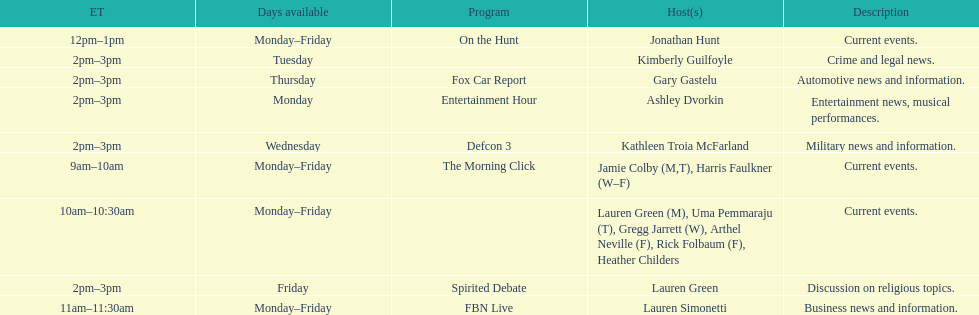Give me the full table as a dictionary. {'header': ['ET', 'Days available', 'Program', 'Host(s)', 'Description'], 'rows': [['12pm–1pm', 'Monday–Friday', 'On the Hunt', 'Jonathan Hunt', 'Current events.'], ['2pm–3pm', 'Tuesday', '', 'Kimberly Guilfoyle', 'Crime and legal news.'], ['2pm–3pm', 'Thursday', 'Fox Car Report', 'Gary Gastelu', 'Automotive news and information.'], ['2pm–3pm', 'Monday', 'Entertainment Hour', 'Ashley Dvorkin', 'Entertainment news, musical performances.'], ['2pm–3pm', 'Wednesday', 'Defcon 3', 'Kathleen Troia McFarland', 'Military news and information.'], ['9am–10am', 'Monday–Friday', 'The Morning Click', 'Jamie Colby (M,T), Harris Faulkner (W–F)', 'Current events.'], ['10am–10:30am', 'Monday–Friday', '', 'Lauren Green (M), Uma Pemmaraju (T), Gregg Jarrett (W), Arthel Neville (F), Rick Folbaum (F), Heather Childers', 'Current events.'], ['2pm–3pm', 'Friday', 'Spirited Debate', 'Lauren Green', 'Discussion on religious topics.'], ['11am–11:30am', 'Monday–Friday', 'FBN Live', 'Lauren Simonetti', 'Business news and information.']]} Tell me who has her show on fridays at 2. Lauren Green. 